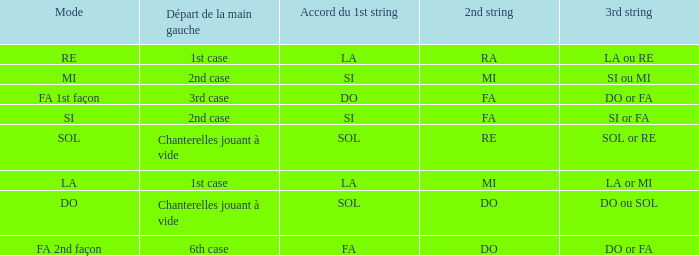What is the mode of the Depart de la main gauche of 1st case and a la or mi 3rd string? LA. 